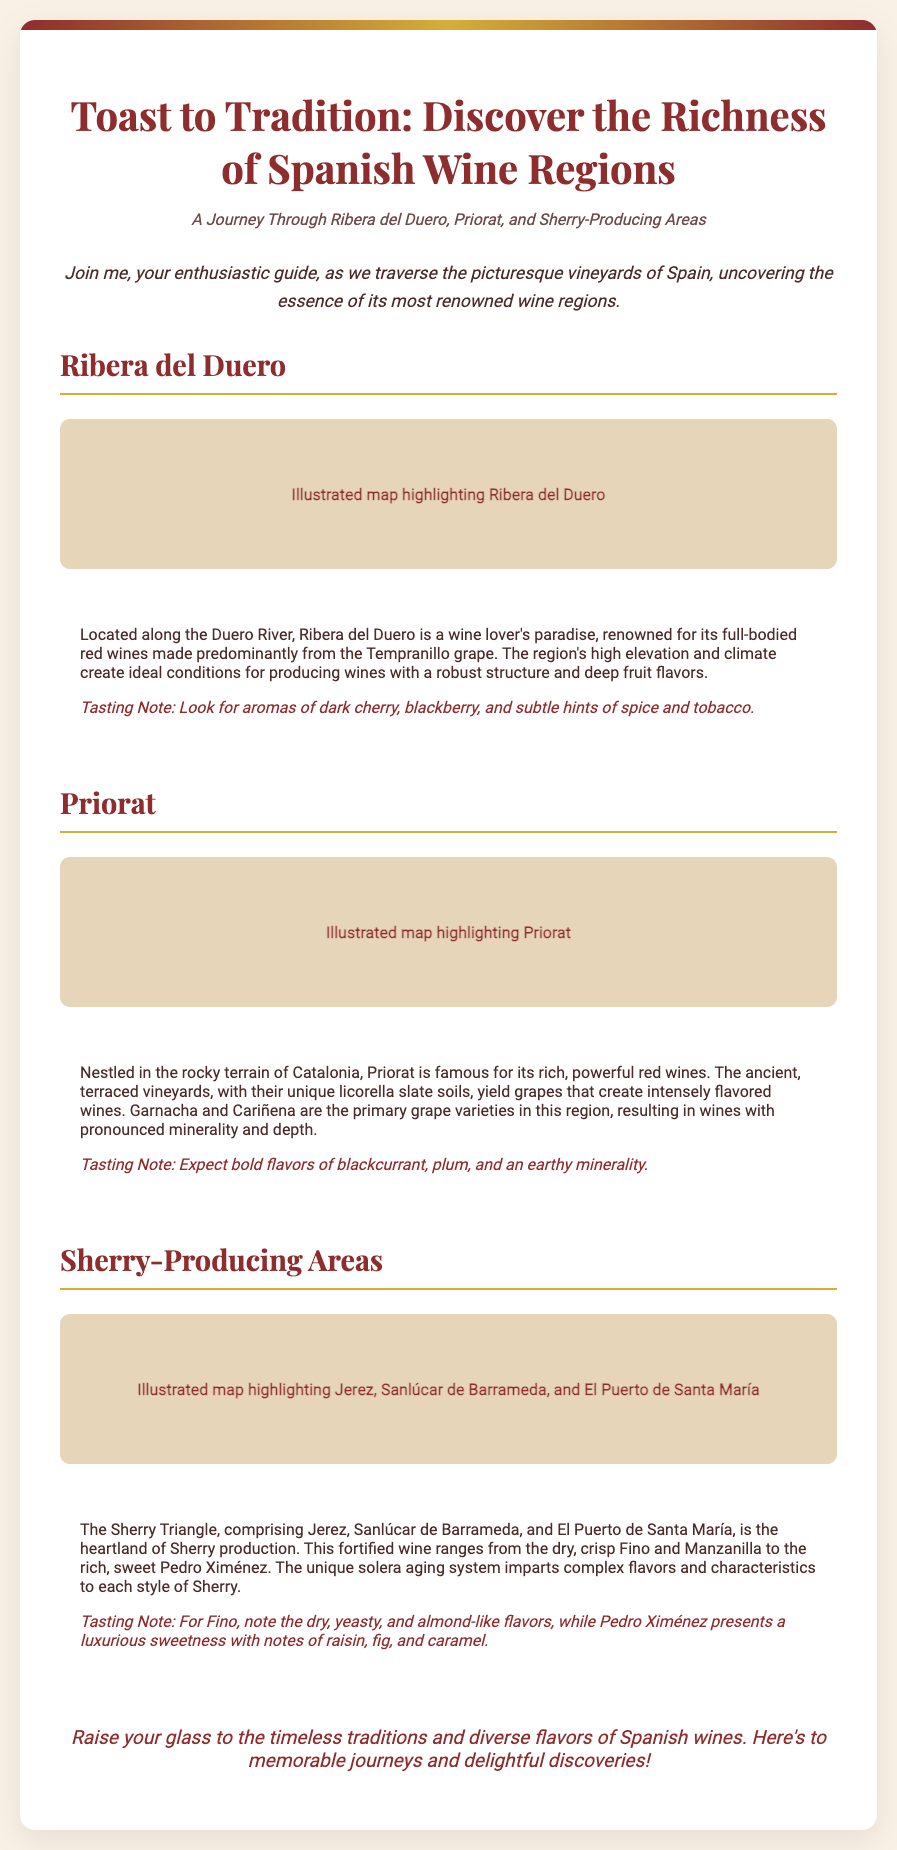what is the title of the greeting card? The title of the greeting card is stated prominently at the top of the card.
Answer: Toast to Tradition: Discover the Richness of Spanish Wine Regions what region produces primarily Tempranillo grapes? The document specifies regions and their primary grapes, identifying Ribera del Duero as the one for Tempranillo.
Answer: Ribera del Duero which grape varieties are highlighted in Priorat? The text mentions the primary grape varieties used in Priorat's wine production.
Answer: Garnacha and Cariñena what type of wine is Fino? The document describes different styles of Sherry, specifying Fino's characteristics.
Answer: Dry how many Sherry-producing areas are mentioned? The greeting card explicitly states the areas that comprise the Sherry Triangle.
Answer: Three what flavors are noted in Ribera del Duero tasting notes? The tasting notes provide specific flavors found in Ribera del Duero wines, including dark fruits and hints of spice.
Answer: Dark cherry, blackberry, spice which region is known for licorella slate soils? The document describes the unique soil found in Priorat and its impact on wine.
Answer: Priorat what is the closing sentiment of the greeting card? The final message of the card encapsulates the overall theme of appreciation for Spanish wines.
Answer: Raise your glass to the timeless traditions and diverse flavors of Spanish wines 